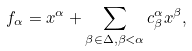Convert formula to latex. <formula><loc_0><loc_0><loc_500><loc_500>f _ { \alpha } = x ^ { \alpha } + \sum _ { \beta \in \Delta , \beta < \alpha } c ^ { \alpha } _ { \beta } x ^ { \beta } ,</formula> 